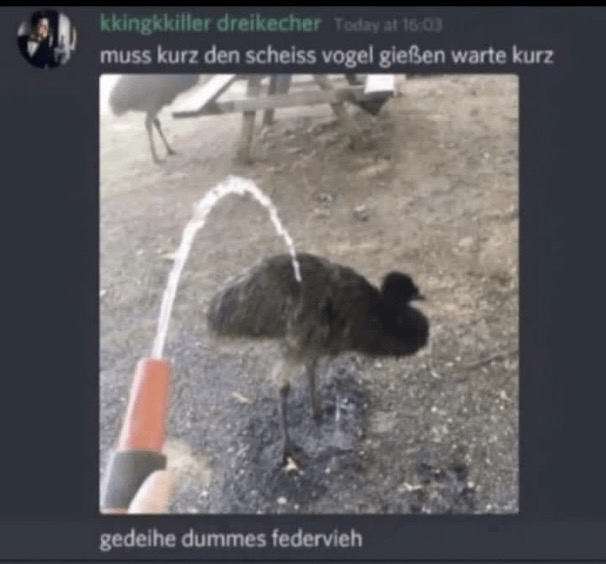What is in this image?
 This image shows someone spraying water from a hose or spray bottle onto a large bird, which appears to be an ostrich or emu. The bird is standing on a dirt or gravel surface. The water is arcing in front of the bird.

The image is a screenshot of a social media post, likely from a German-language platform based on the text. The caption at the top roughly translates to "have to quickly water the crappy bird, wait a moment." At the bottom, there's another comment in German that roughly means "thrive, stupid feathered creature."

The tone of the post seems to be humorous or sarcastic, treating the large bird as if it were a plant that needs watering. However, spraying water on animals in this manner could be seen as disrespectful or potentially harmful, depending on the context. 